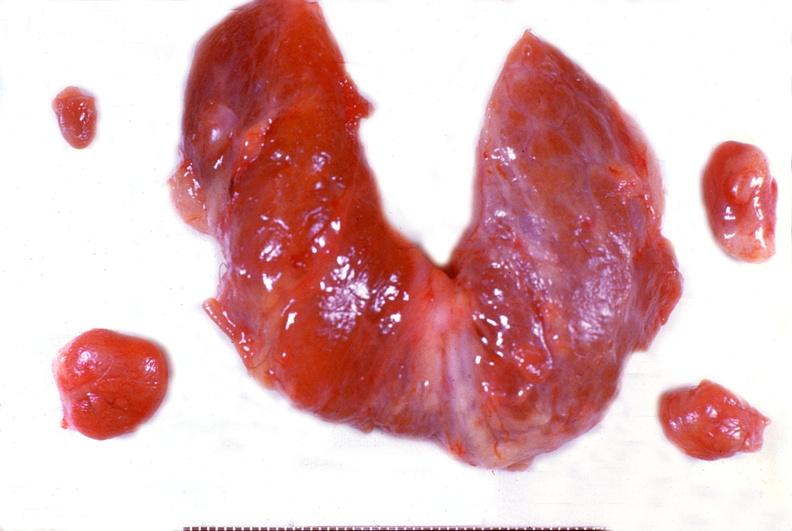does endocrine show parathyroid hyperplasia?
Answer the question using a single word or phrase. No 